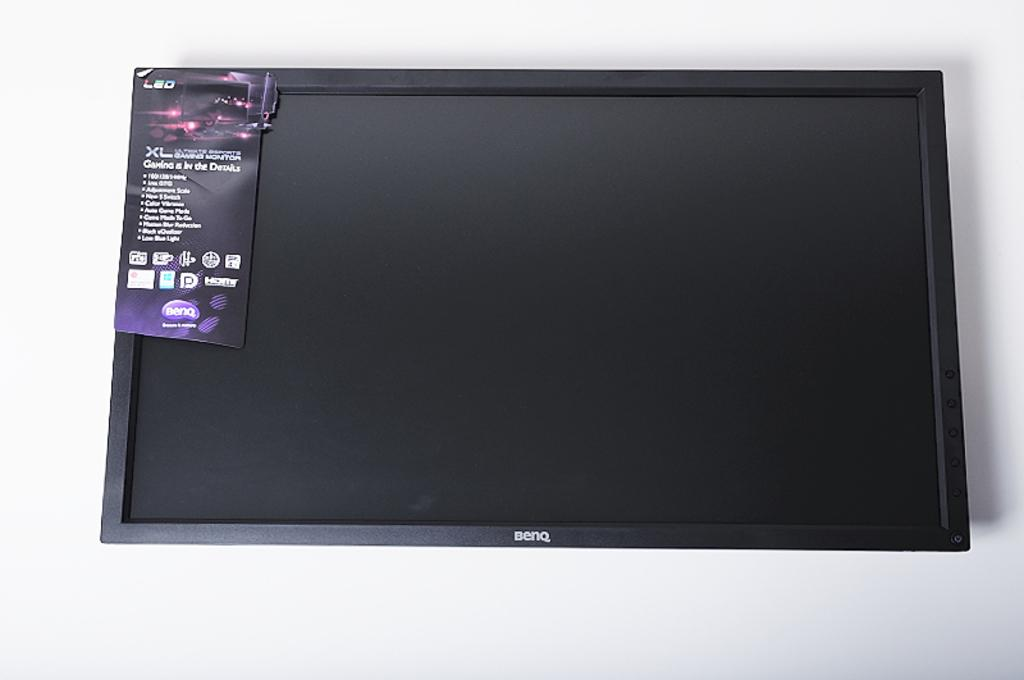What electronic device is present in the image? There is a TV in the image. How is the TV positioned in the room? The TV is hanged on the wall. What is the color of the TV? The TV is black in color. Is there any additional detail on the TV? Yes, there is a sticker on the TV. What color is the wall behind the TV? The background wall is white in color. What type of shoes are hanging on the cactus in the image? There is no cactus or shoes present in the image; it features a TV hung on a white wall with a sticker on it. 